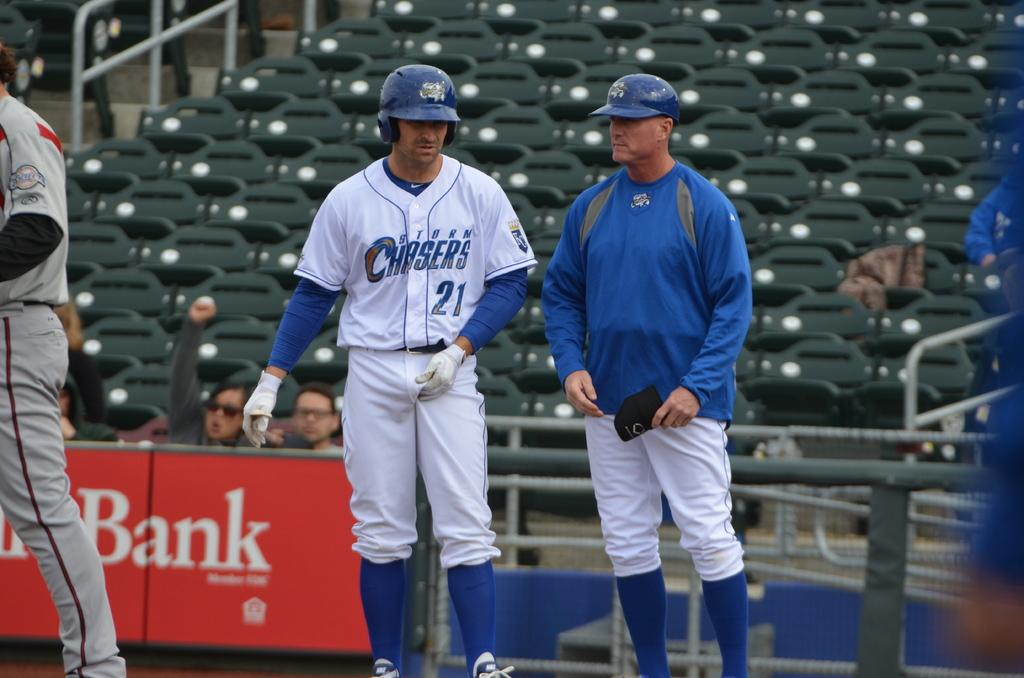<image>
Relay a brief, clear account of the picture shown. a baseball player the has the team name and 21 on his jersey 